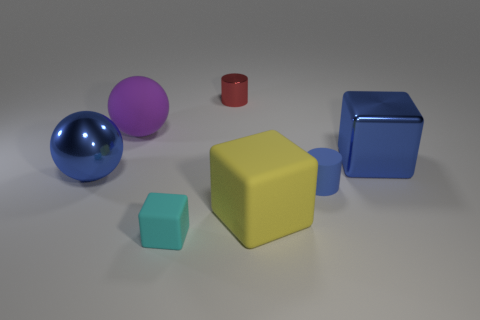Add 2 big metallic blocks. How many objects exist? 9 Subtract all blocks. How many objects are left? 4 Subtract all cyan balls. Subtract all yellow matte blocks. How many objects are left? 6 Add 5 big blue metal balls. How many big blue metal balls are left? 6 Add 7 big purple matte spheres. How many big purple matte spheres exist? 8 Subtract 0 red cubes. How many objects are left? 7 